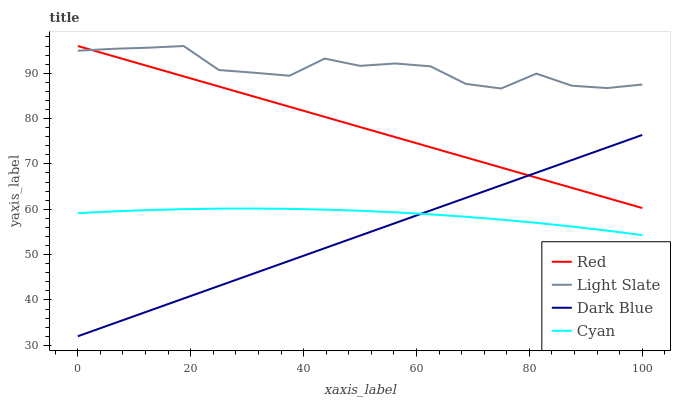Does Dark Blue have the minimum area under the curve?
Answer yes or no. Yes. Does Light Slate have the maximum area under the curve?
Answer yes or no. Yes. Does Red have the minimum area under the curve?
Answer yes or no. No. Does Red have the maximum area under the curve?
Answer yes or no. No. Is Red the smoothest?
Answer yes or no. Yes. Is Light Slate the roughest?
Answer yes or no. Yes. Is Dark Blue the smoothest?
Answer yes or no. No. Is Dark Blue the roughest?
Answer yes or no. No. Does Red have the lowest value?
Answer yes or no. No. Does Red have the highest value?
Answer yes or no. Yes. Does Dark Blue have the highest value?
Answer yes or no. No. Is Dark Blue less than Light Slate?
Answer yes or no. Yes. Is Light Slate greater than Cyan?
Answer yes or no. Yes. Does Dark Blue intersect Cyan?
Answer yes or no. Yes. Is Dark Blue less than Cyan?
Answer yes or no. No. Is Dark Blue greater than Cyan?
Answer yes or no. No. Does Dark Blue intersect Light Slate?
Answer yes or no. No. 